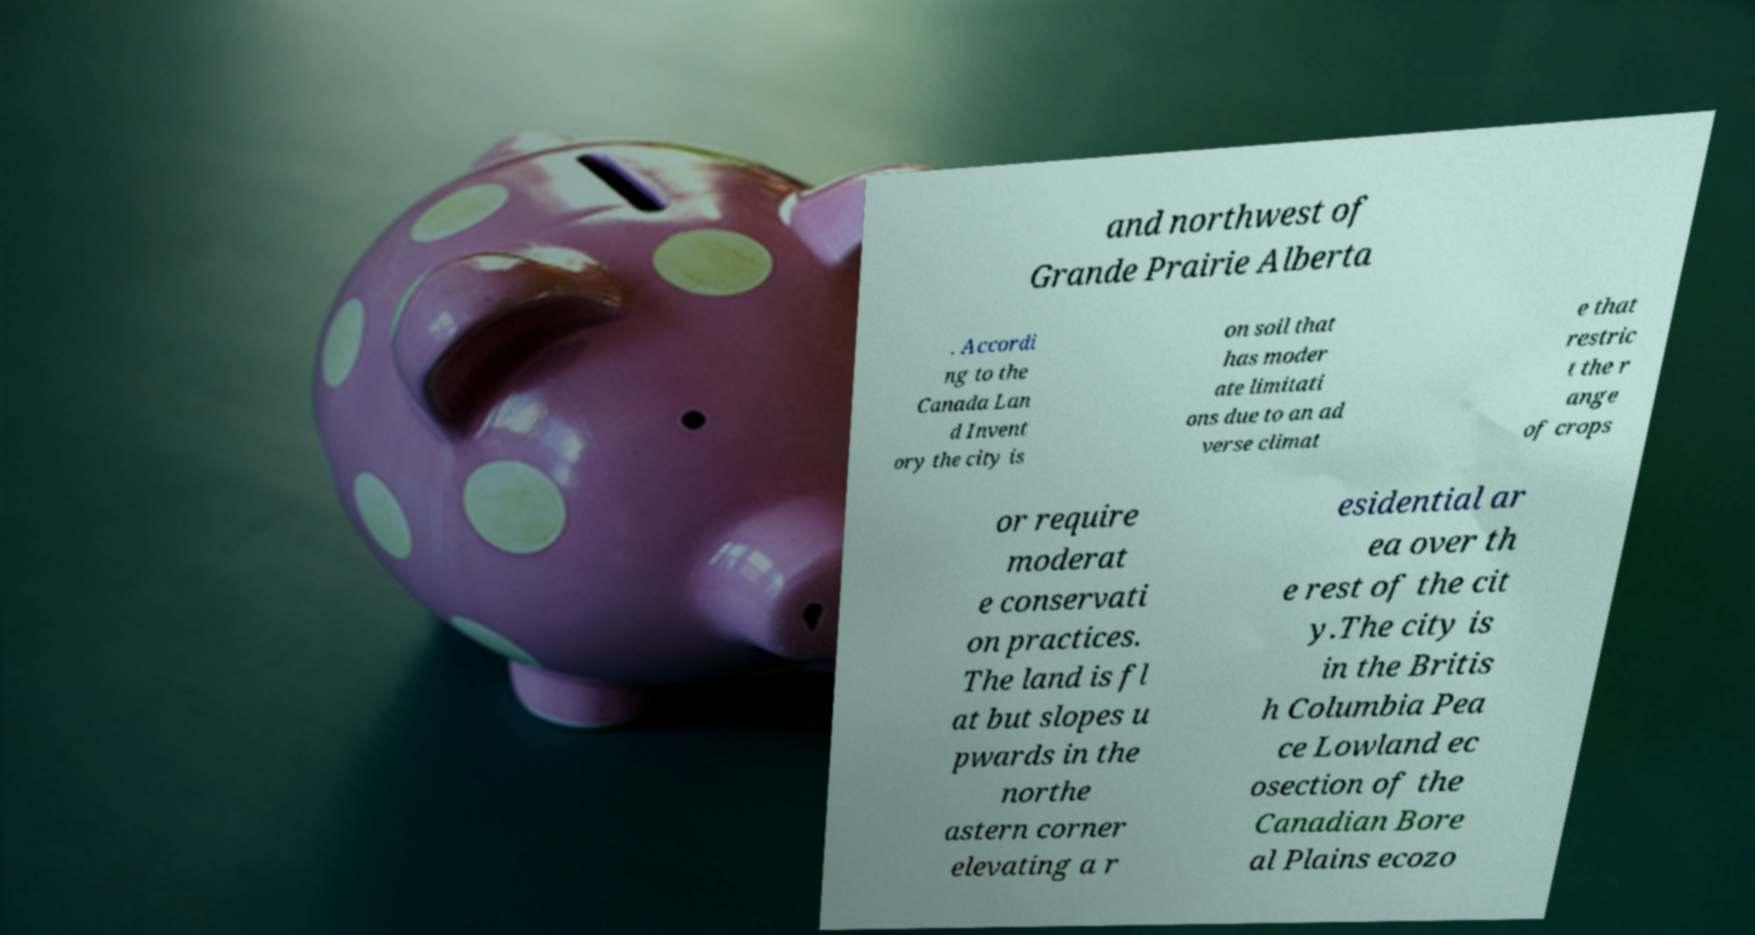For documentation purposes, I need the text within this image transcribed. Could you provide that? and northwest of Grande Prairie Alberta . Accordi ng to the Canada Lan d Invent ory the city is on soil that has moder ate limitati ons due to an ad verse climat e that restric t the r ange of crops or require moderat e conservati on practices. The land is fl at but slopes u pwards in the northe astern corner elevating a r esidential ar ea over th e rest of the cit y.The city is in the Britis h Columbia Pea ce Lowland ec osection of the Canadian Bore al Plains ecozo 